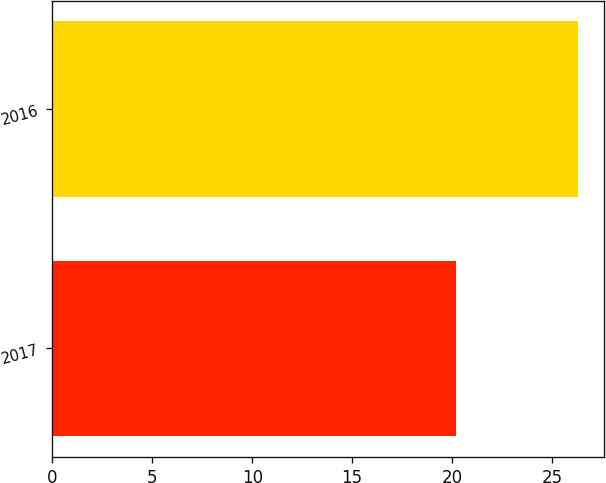<chart> <loc_0><loc_0><loc_500><loc_500><bar_chart><fcel>2017<fcel>2016<nl><fcel>20.2<fcel>26.3<nl></chart> 